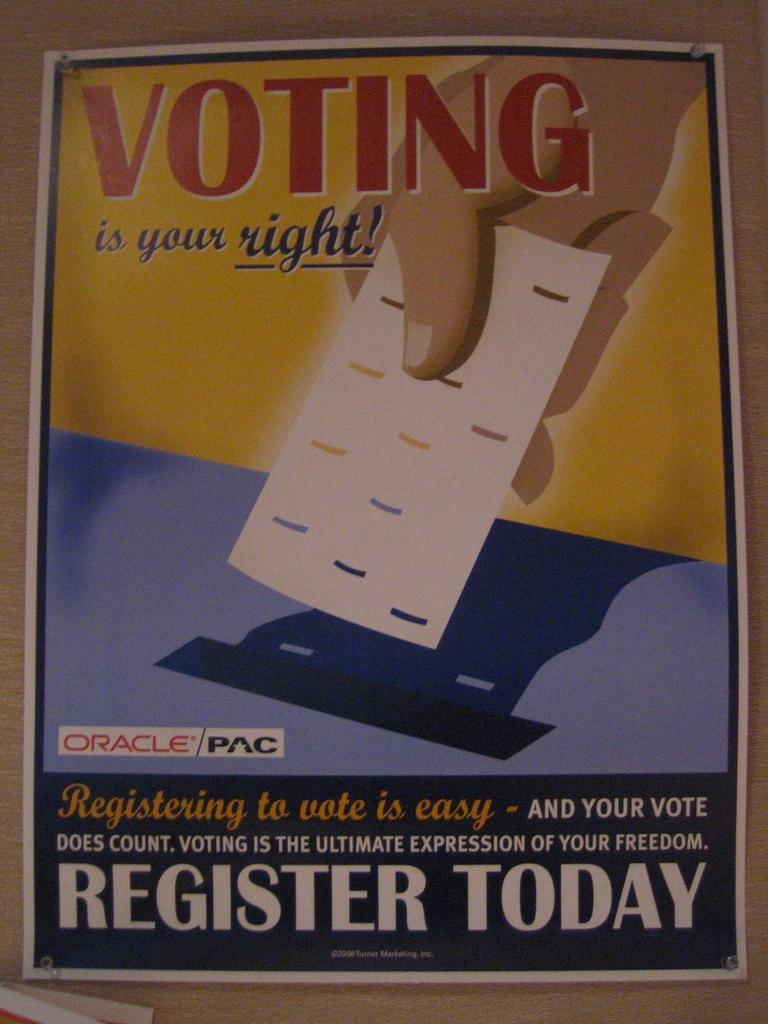<image>
Write a terse but informative summary of the picture. a yellow and blue advertisement telling how voting is your right and to register today 